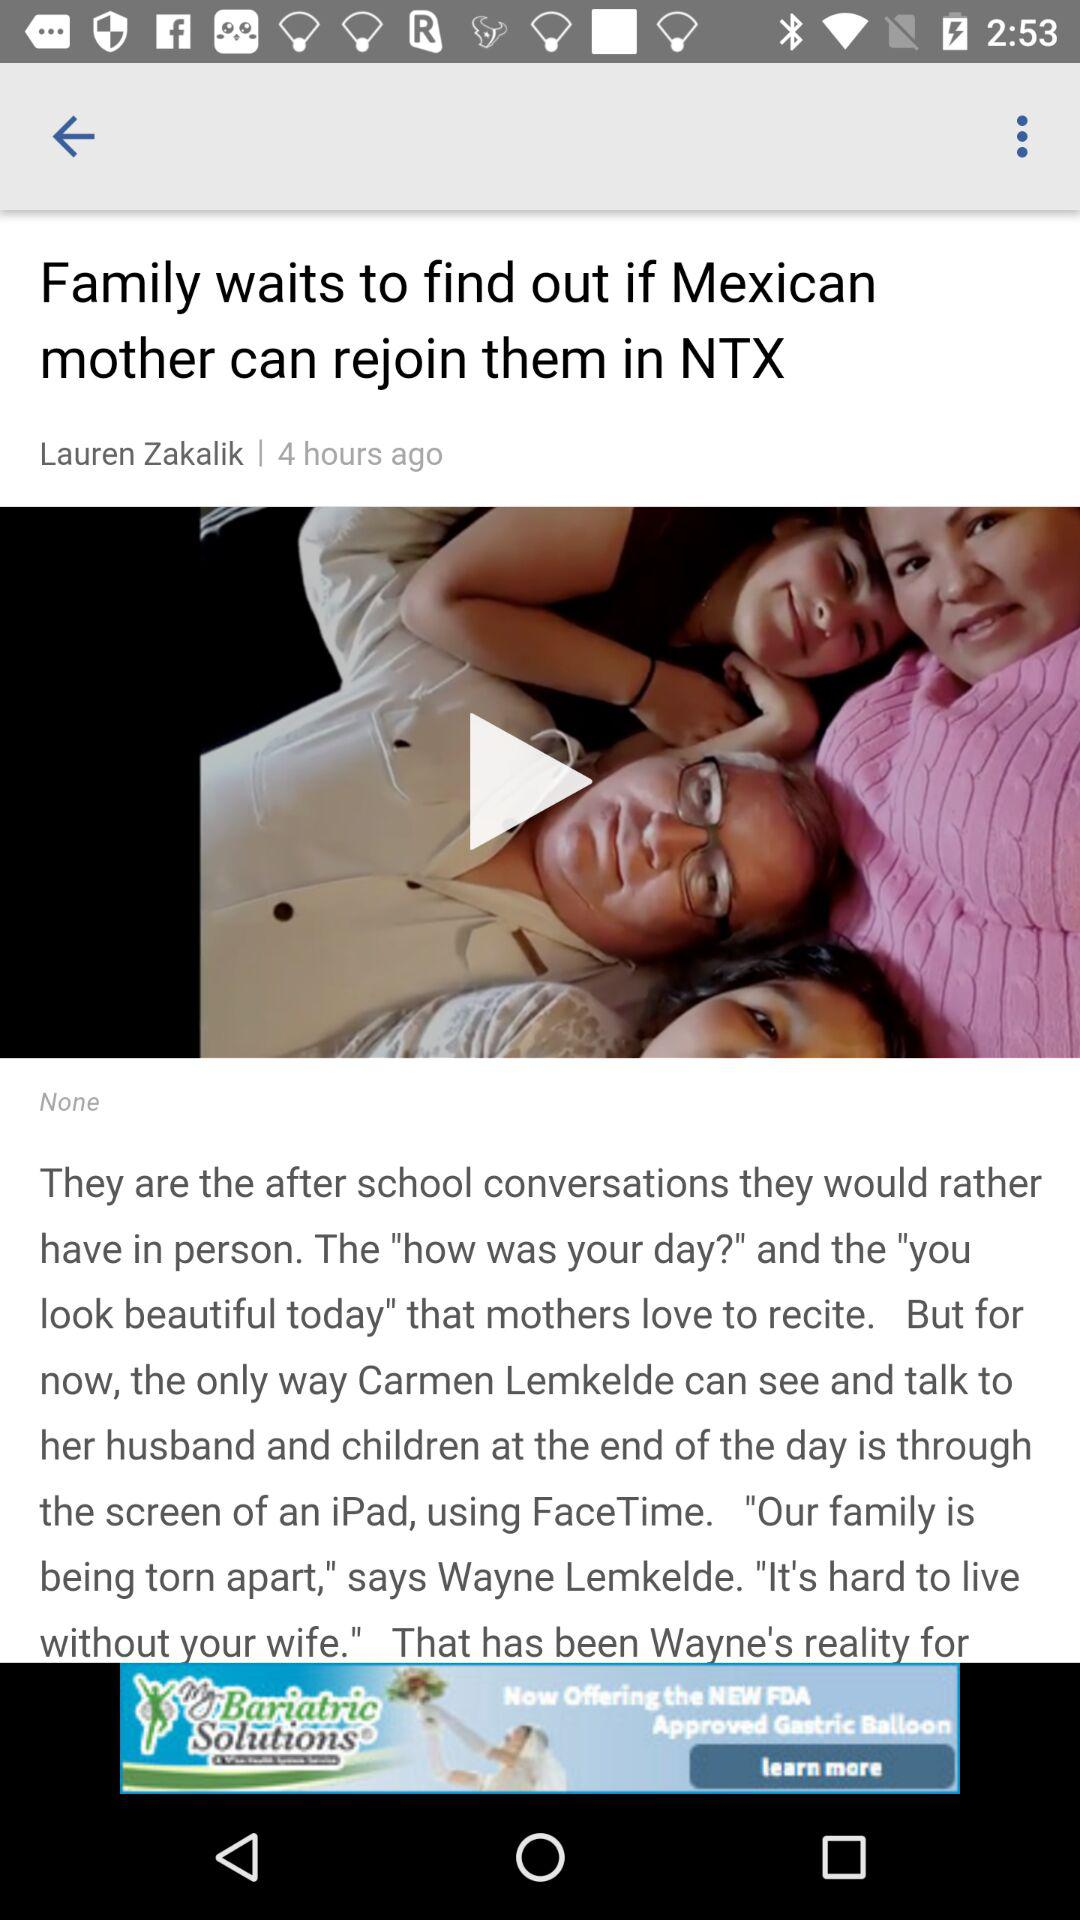How long ago did Lauren Zakalik post? Lauren Zakalik posted 4 hours ago. 